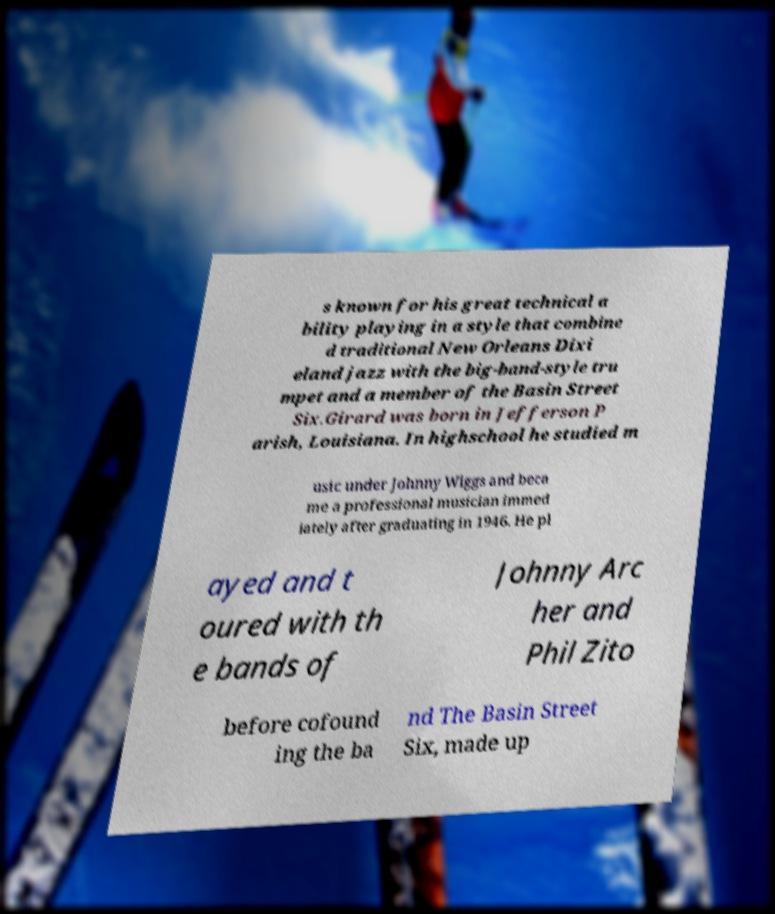Could you assist in decoding the text presented in this image and type it out clearly? s known for his great technical a bility playing in a style that combine d traditional New Orleans Dixi eland jazz with the big-band-style tru mpet and a member of the Basin Street Six.Girard was born in Jefferson P arish, Louisiana. In highschool he studied m usic under Johnny Wiggs and beca me a professional musician immed iately after graduating in 1946. He pl ayed and t oured with th e bands of Johnny Arc her and Phil Zito before cofound ing the ba nd The Basin Street Six, made up 